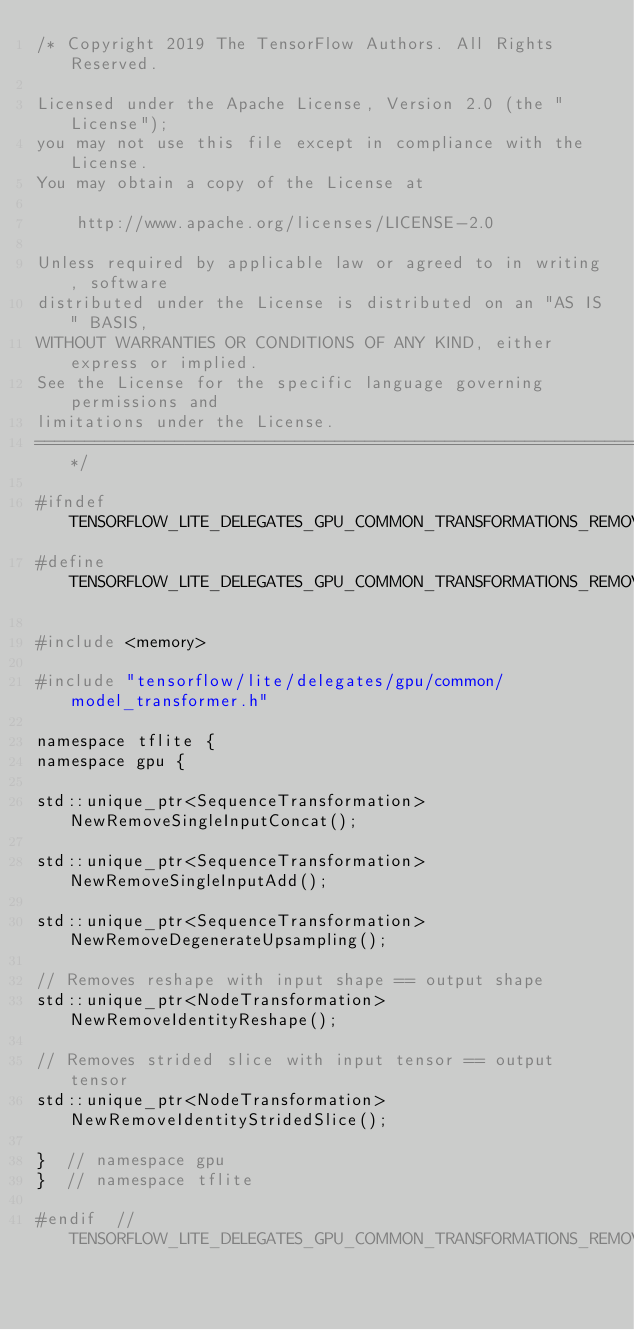<code> <loc_0><loc_0><loc_500><loc_500><_C_>/* Copyright 2019 The TensorFlow Authors. All Rights Reserved.

Licensed under the Apache License, Version 2.0 (the "License");
you may not use this file except in compliance with the License.
You may obtain a copy of the License at

    http://www.apache.org/licenses/LICENSE-2.0

Unless required by applicable law or agreed to in writing, software
distributed under the License is distributed on an "AS IS" BASIS,
WITHOUT WARRANTIES OR CONDITIONS OF ANY KIND, either express or implied.
See the License for the specific language governing permissions and
limitations under the License.
==============================================================================*/

#ifndef TENSORFLOW_LITE_DELEGATES_GPU_COMMON_TRANSFORMATIONS_REMOVE_NOOP_H_
#define TENSORFLOW_LITE_DELEGATES_GPU_COMMON_TRANSFORMATIONS_REMOVE_NOOP_H_

#include <memory>

#include "tensorflow/lite/delegates/gpu/common/model_transformer.h"

namespace tflite {
namespace gpu {

std::unique_ptr<SequenceTransformation> NewRemoveSingleInputConcat();

std::unique_ptr<SequenceTransformation> NewRemoveSingleInputAdd();

std::unique_ptr<SequenceTransformation> NewRemoveDegenerateUpsampling();

// Removes reshape with input shape == output shape
std::unique_ptr<NodeTransformation> NewRemoveIdentityReshape();

// Removes strided slice with input tensor == output tensor
std::unique_ptr<NodeTransformation> NewRemoveIdentityStridedSlice();

}  // namespace gpu
}  // namespace tflite

#endif  // TENSORFLOW_LITE_DELEGATES_GPU_COMMON_TRANSFORMATIONS_REMOVE_NOOP_H_
</code> 